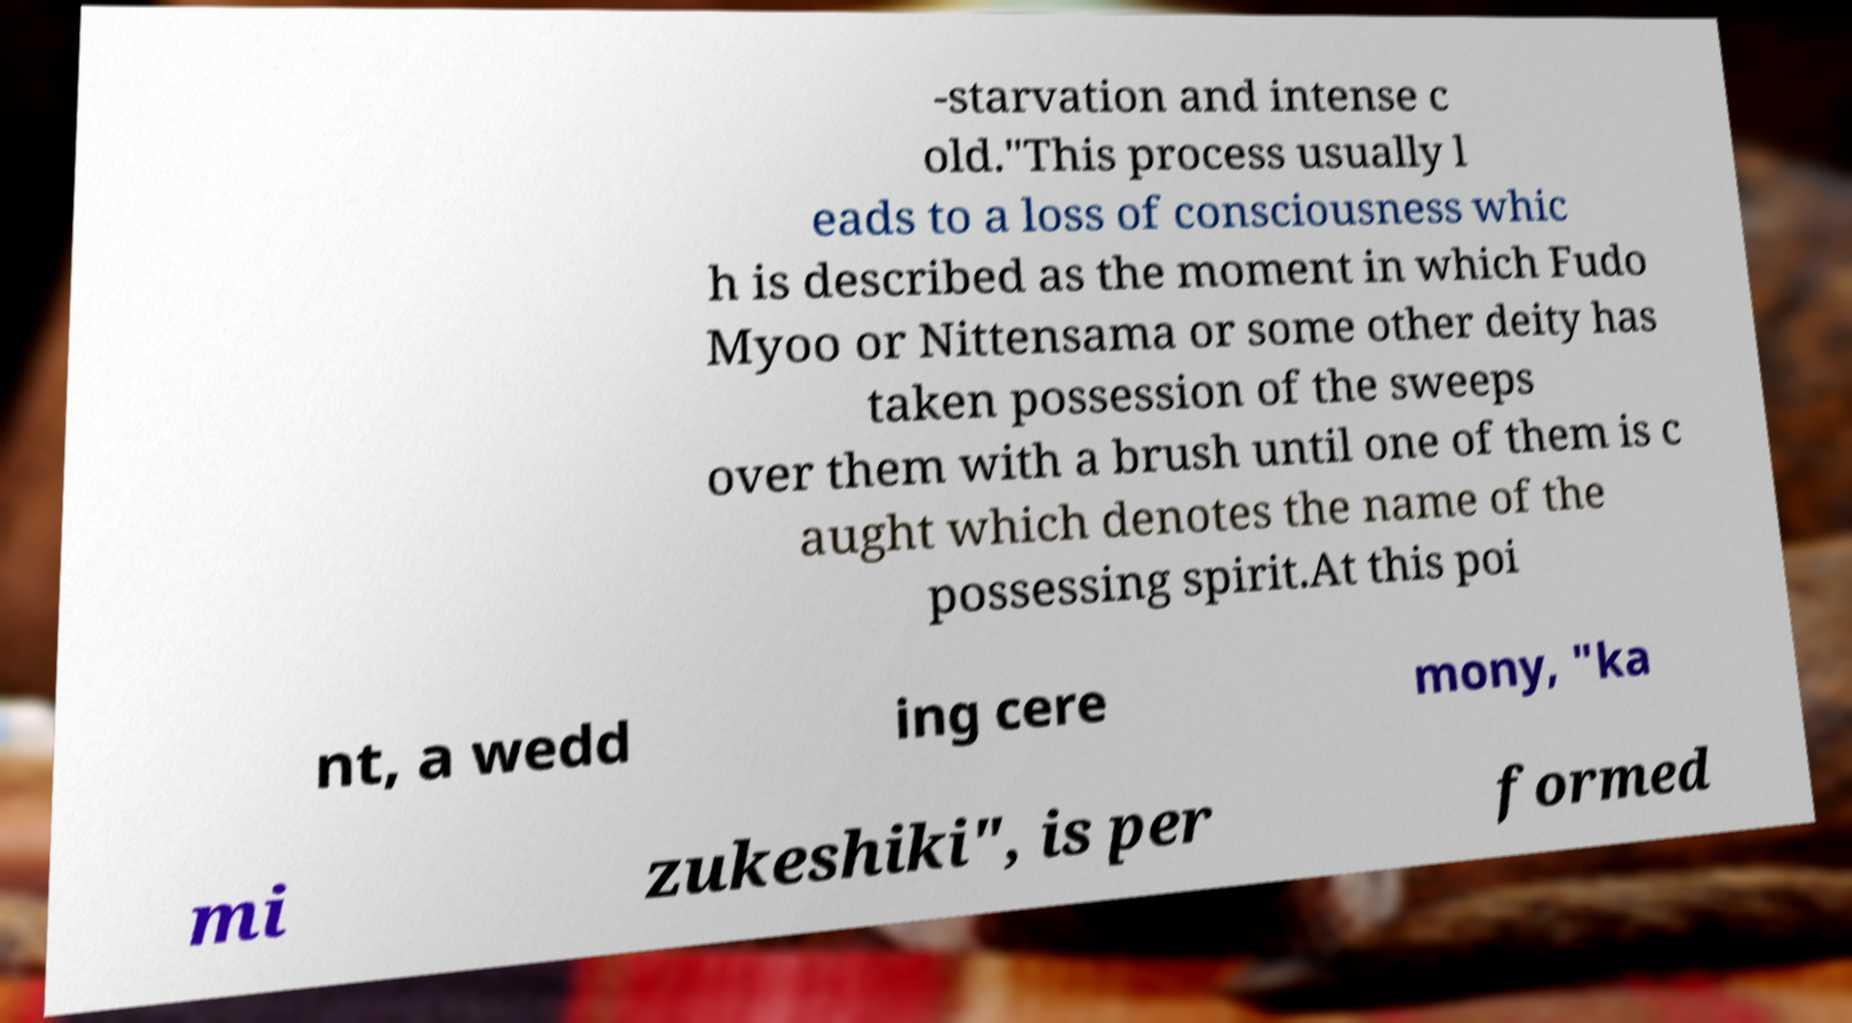Can you read and provide the text displayed in the image?This photo seems to have some interesting text. Can you extract and type it out for me? -starvation and intense c old."This process usually l eads to a loss of consciousness whic h is described as the moment in which Fudo Myoo or Nittensama or some other deity has taken possession of the sweeps over them with a brush until one of them is c aught which denotes the name of the possessing spirit.At this poi nt, a wedd ing cere mony, "ka mi zukeshiki", is per formed 